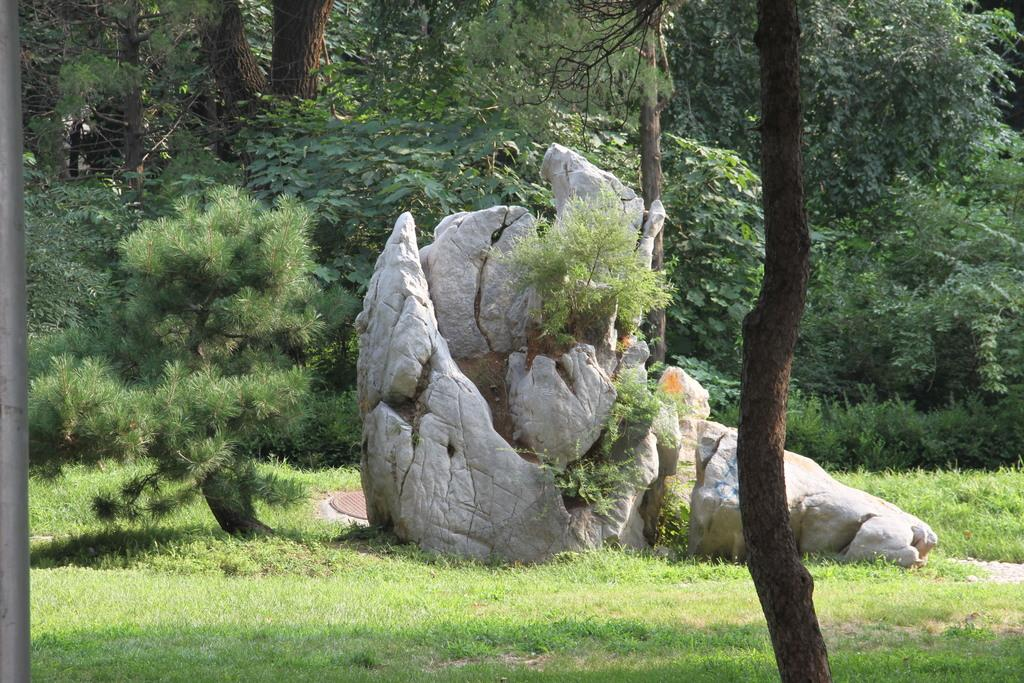What type of vegetation can be seen in the image? There are trees in the image. What is the ground covered with in the image? There is grass in the image. What is the other object visible in the image? There is a stone in the image. What type of fog can be seen in the image? There is no fog present in the image; it features trees, grass, and a stone. 